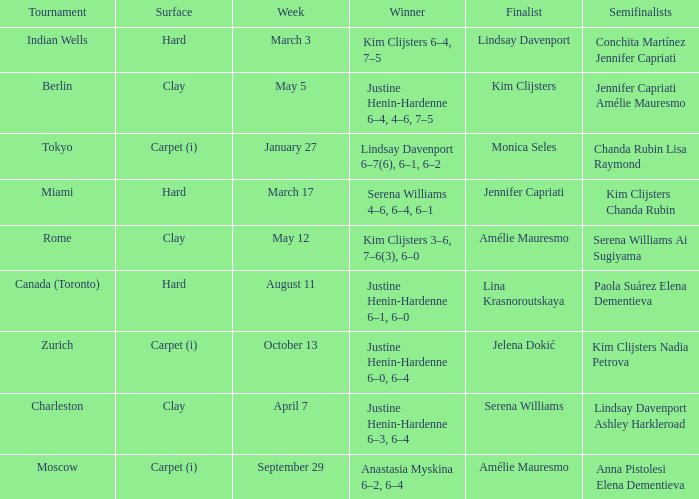Who was the winner against Lindsay Davenport? Kim Clijsters 6–4, 7–5. 